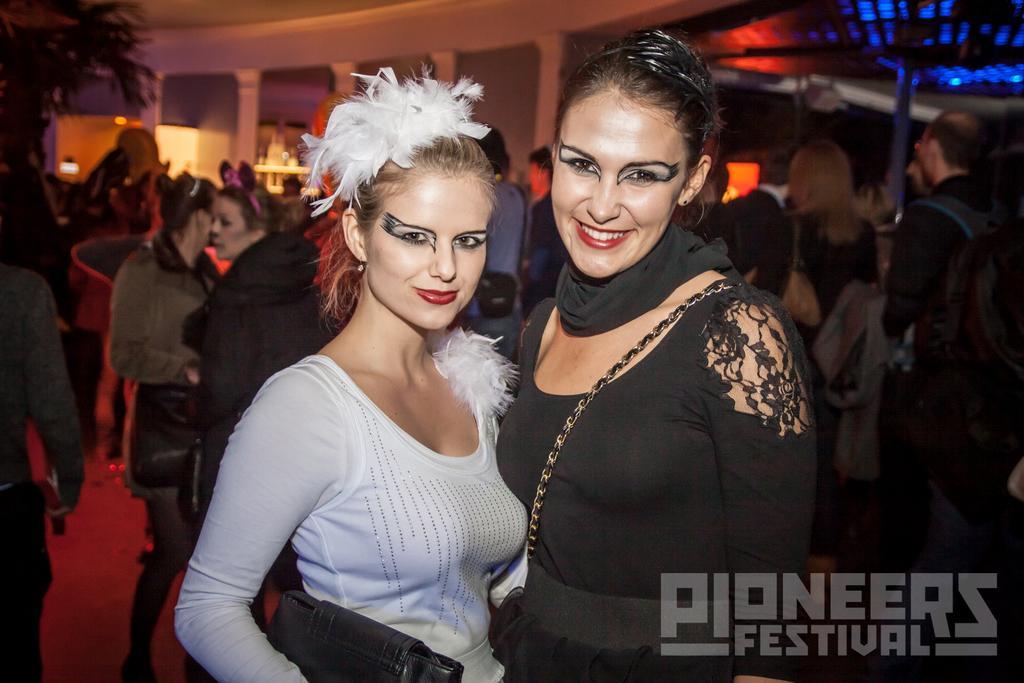Can you describe this image briefly? In this picture we can see a group of people. Behind the people, there are pillars, a tree and lights. In the bottom right corner of the image, there is a watermark. 